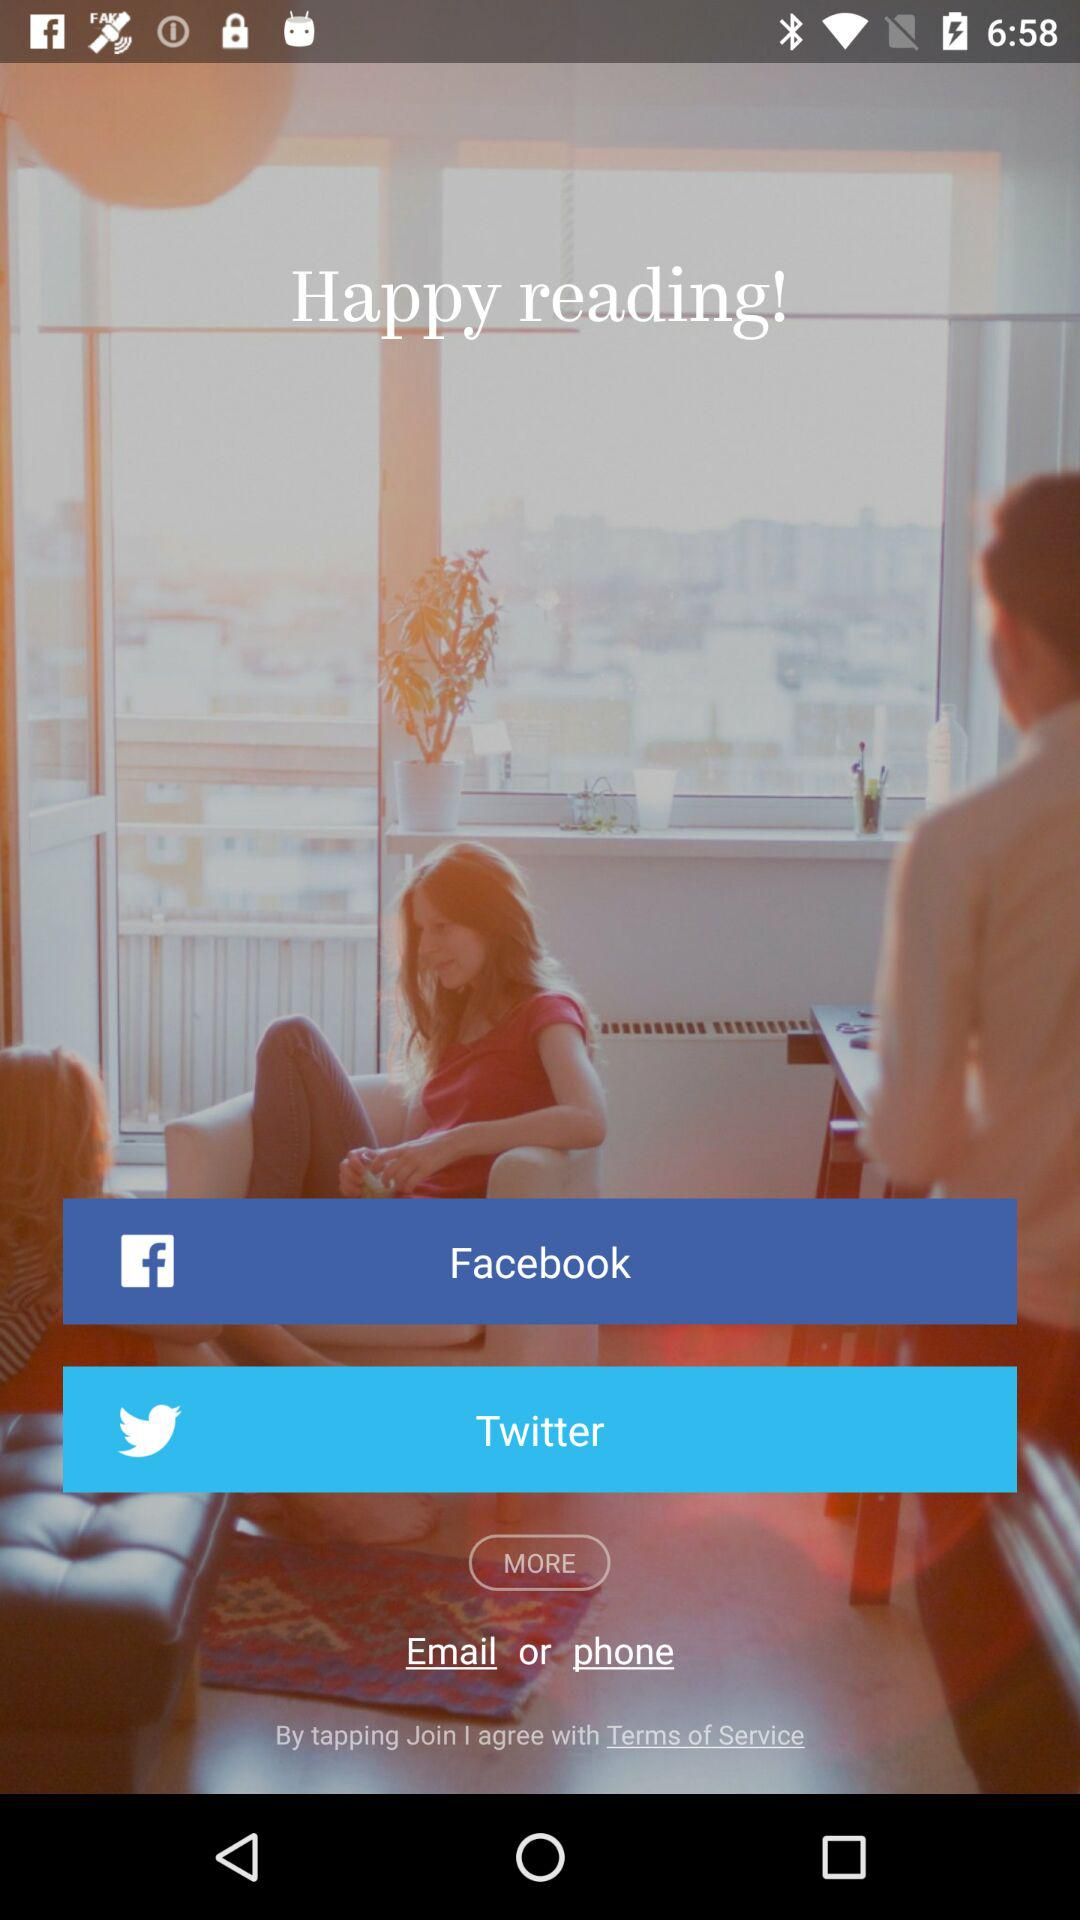Through which app can we share? You can share through "Facebook" and "Twitter". 